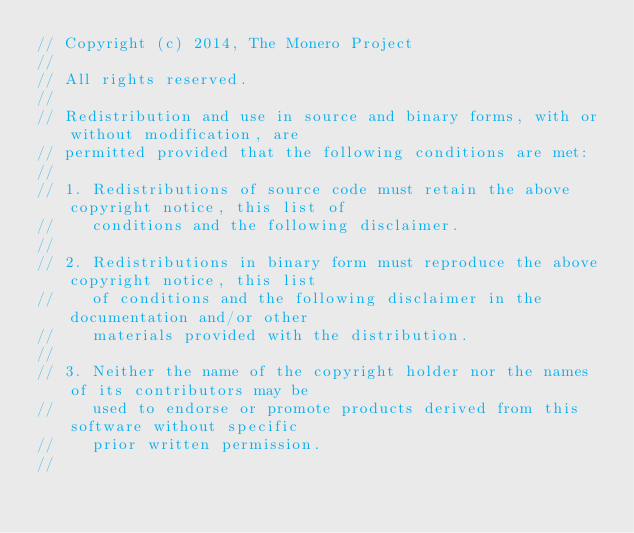<code> <loc_0><loc_0><loc_500><loc_500><_C_>// Copyright (c) 2014, The Monero Project
// 
// All rights reserved.
// 
// Redistribution and use in source and binary forms, with or without modification, are
// permitted provided that the following conditions are met:
// 
// 1. Redistributions of source code must retain the above copyright notice, this list of
//    conditions and the following disclaimer.
// 
// 2. Redistributions in binary form must reproduce the above copyright notice, this list
//    of conditions and the following disclaimer in the documentation and/or other
//    materials provided with the distribution.
// 
// 3. Neither the name of the copyright holder nor the names of its contributors may be
//    used to endorse or promote products derived from this software without specific
//    prior written permission.
// </code> 